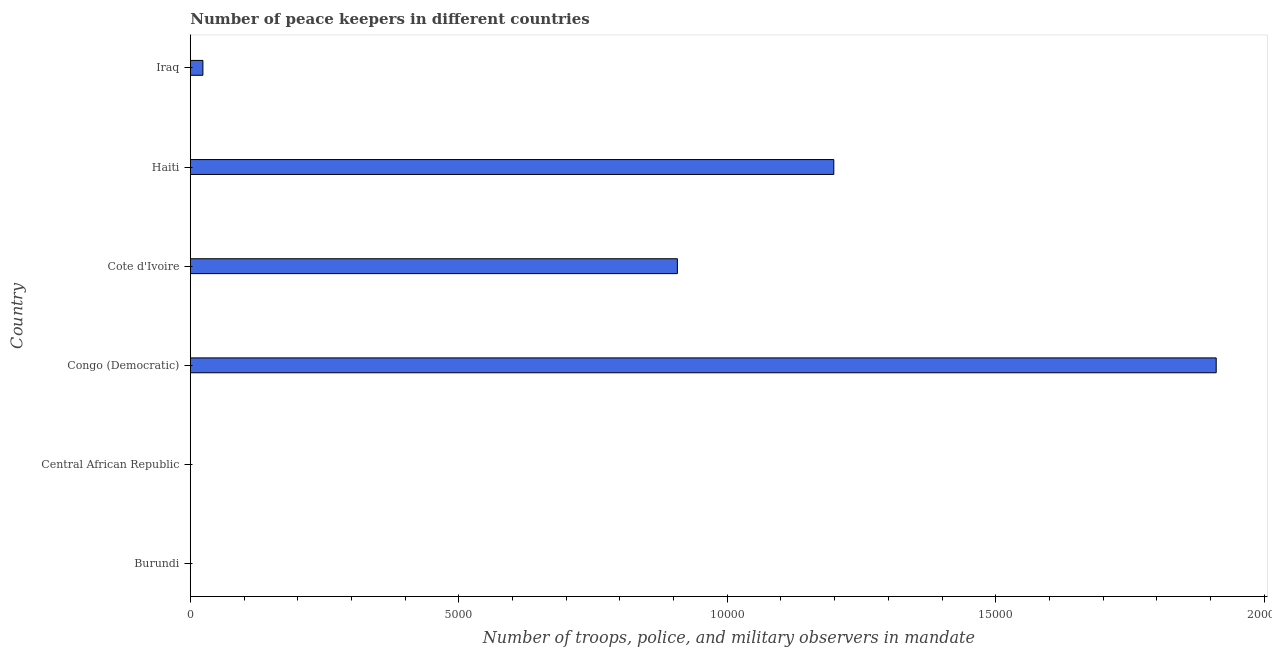Does the graph contain grids?
Provide a short and direct response. No. What is the title of the graph?
Keep it short and to the point. Number of peace keepers in different countries. What is the label or title of the X-axis?
Your answer should be very brief. Number of troops, police, and military observers in mandate. What is the label or title of the Y-axis?
Your answer should be compact. Country. Across all countries, what is the maximum number of peace keepers?
Ensure brevity in your answer.  1.91e+04. In which country was the number of peace keepers maximum?
Make the answer very short. Congo (Democratic). In which country was the number of peace keepers minimum?
Your response must be concise. Central African Republic. What is the sum of the number of peace keepers?
Your response must be concise. 4.04e+04. What is the difference between the number of peace keepers in Burundi and Central African Republic?
Give a very brief answer. 1. What is the average number of peace keepers per country?
Your answer should be very brief. 6733. What is the median number of peace keepers?
Your response must be concise. 4653. In how many countries, is the number of peace keepers greater than 12000 ?
Make the answer very short. 1. What is the ratio of the number of peace keepers in Cote d'Ivoire to that in Iraq?
Ensure brevity in your answer.  38.6. What is the difference between the highest and the second highest number of peace keepers?
Ensure brevity in your answer.  7121. What is the difference between the highest and the lowest number of peace keepers?
Give a very brief answer. 1.91e+04. In how many countries, is the number of peace keepers greater than the average number of peace keepers taken over all countries?
Offer a very short reply. 3. How many bars are there?
Your answer should be compact. 6. Are the values on the major ticks of X-axis written in scientific E-notation?
Offer a terse response. No. What is the Number of troops, police, and military observers in mandate in Burundi?
Give a very brief answer. 4. What is the Number of troops, police, and military observers in mandate in Central African Republic?
Offer a very short reply. 3. What is the Number of troops, police, and military observers in mandate in Congo (Democratic)?
Provide a succinct answer. 1.91e+04. What is the Number of troops, police, and military observers in mandate of Cote d'Ivoire?
Your response must be concise. 9071. What is the Number of troops, police, and military observers in mandate in Haiti?
Keep it short and to the point. 1.20e+04. What is the Number of troops, police, and military observers in mandate in Iraq?
Your response must be concise. 235. What is the difference between the Number of troops, police, and military observers in mandate in Burundi and Central African Republic?
Provide a succinct answer. 1. What is the difference between the Number of troops, police, and military observers in mandate in Burundi and Congo (Democratic)?
Offer a very short reply. -1.91e+04. What is the difference between the Number of troops, police, and military observers in mandate in Burundi and Cote d'Ivoire?
Keep it short and to the point. -9067. What is the difference between the Number of troops, police, and military observers in mandate in Burundi and Haiti?
Provide a succinct answer. -1.20e+04. What is the difference between the Number of troops, police, and military observers in mandate in Burundi and Iraq?
Your answer should be compact. -231. What is the difference between the Number of troops, police, and military observers in mandate in Central African Republic and Congo (Democratic)?
Provide a succinct answer. -1.91e+04. What is the difference between the Number of troops, police, and military observers in mandate in Central African Republic and Cote d'Ivoire?
Offer a terse response. -9068. What is the difference between the Number of troops, police, and military observers in mandate in Central African Republic and Haiti?
Your answer should be very brief. -1.20e+04. What is the difference between the Number of troops, police, and military observers in mandate in Central African Republic and Iraq?
Keep it short and to the point. -232. What is the difference between the Number of troops, police, and military observers in mandate in Congo (Democratic) and Cote d'Ivoire?
Provide a short and direct response. 1.00e+04. What is the difference between the Number of troops, police, and military observers in mandate in Congo (Democratic) and Haiti?
Your answer should be compact. 7121. What is the difference between the Number of troops, police, and military observers in mandate in Congo (Democratic) and Iraq?
Offer a terse response. 1.89e+04. What is the difference between the Number of troops, police, and military observers in mandate in Cote d'Ivoire and Haiti?
Your answer should be very brief. -2913. What is the difference between the Number of troops, police, and military observers in mandate in Cote d'Ivoire and Iraq?
Provide a succinct answer. 8836. What is the difference between the Number of troops, police, and military observers in mandate in Haiti and Iraq?
Keep it short and to the point. 1.17e+04. What is the ratio of the Number of troops, police, and military observers in mandate in Burundi to that in Central African Republic?
Offer a very short reply. 1.33. What is the ratio of the Number of troops, police, and military observers in mandate in Burundi to that in Haiti?
Give a very brief answer. 0. What is the ratio of the Number of troops, police, and military observers in mandate in Burundi to that in Iraq?
Provide a short and direct response. 0.02. What is the ratio of the Number of troops, police, and military observers in mandate in Central African Republic to that in Cote d'Ivoire?
Provide a short and direct response. 0. What is the ratio of the Number of troops, police, and military observers in mandate in Central African Republic to that in Iraq?
Your answer should be very brief. 0.01. What is the ratio of the Number of troops, police, and military observers in mandate in Congo (Democratic) to that in Cote d'Ivoire?
Keep it short and to the point. 2.11. What is the ratio of the Number of troops, police, and military observers in mandate in Congo (Democratic) to that in Haiti?
Your response must be concise. 1.59. What is the ratio of the Number of troops, police, and military observers in mandate in Congo (Democratic) to that in Iraq?
Make the answer very short. 81.3. What is the ratio of the Number of troops, police, and military observers in mandate in Cote d'Ivoire to that in Haiti?
Make the answer very short. 0.76. What is the ratio of the Number of troops, police, and military observers in mandate in Cote d'Ivoire to that in Iraq?
Your answer should be very brief. 38.6. What is the ratio of the Number of troops, police, and military observers in mandate in Haiti to that in Iraq?
Offer a very short reply. 51. 